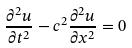Convert formula to latex. <formula><loc_0><loc_0><loc_500><loc_500>\frac { \partial ^ { 2 } u } { \partial t ^ { 2 } } - c ^ { 2 } \frac { \partial ^ { 2 } u } { \partial x ^ { 2 } } = 0</formula> 